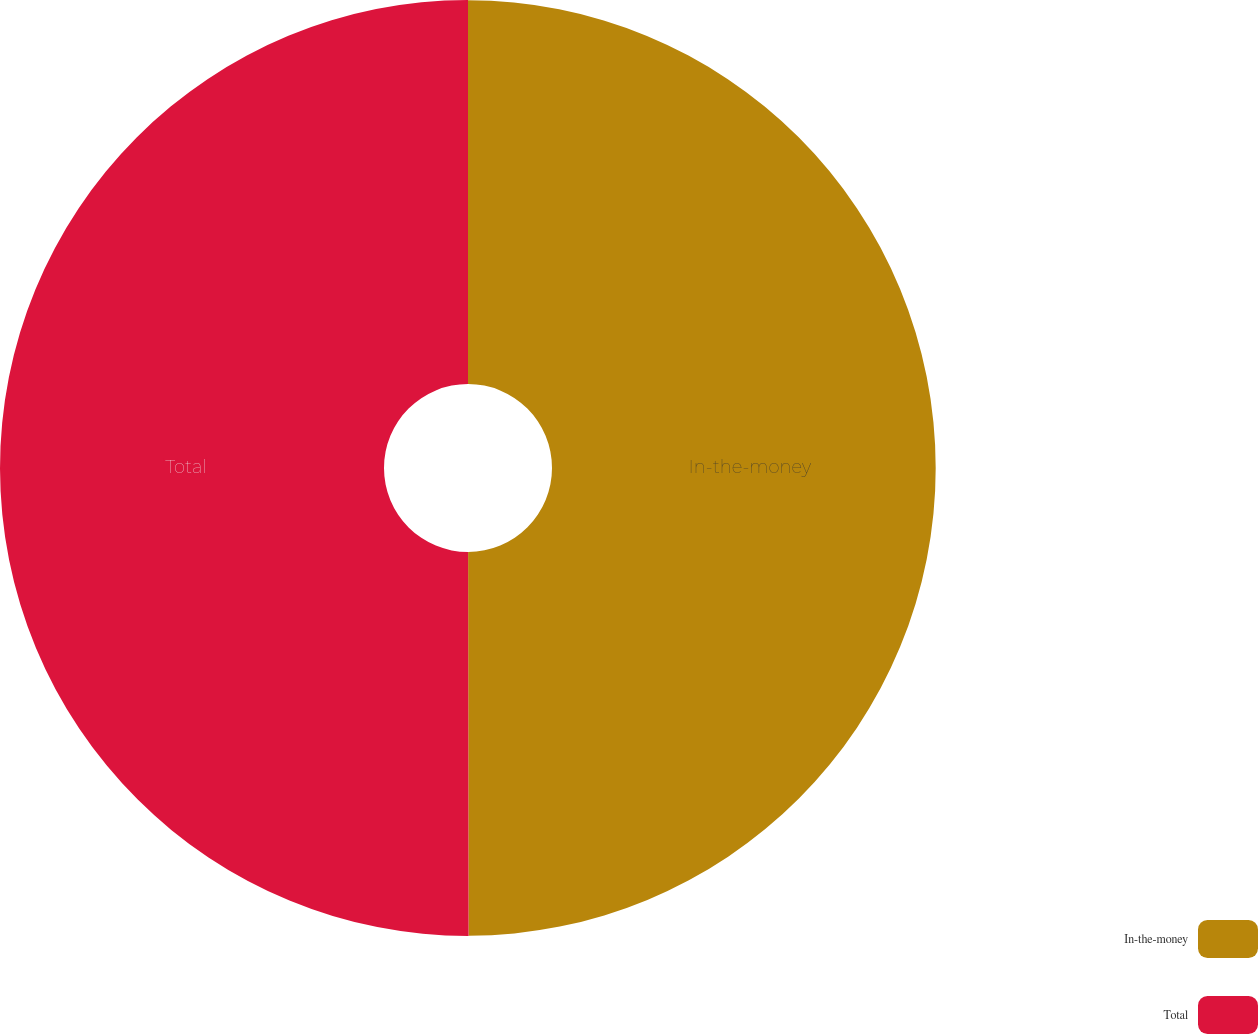Convert chart. <chart><loc_0><loc_0><loc_500><loc_500><pie_chart><fcel>In-the-money<fcel>Total<nl><fcel>49.98%<fcel>50.02%<nl></chart> 